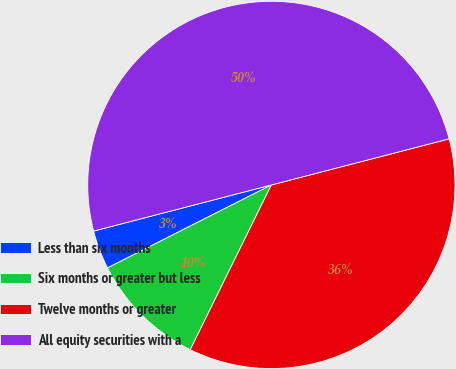Convert chart. <chart><loc_0><loc_0><loc_500><loc_500><pie_chart><fcel>Less than six months<fcel>Six months or greater but less<fcel>Twelve months or greater<fcel>All equity securities with a<nl><fcel>3.42%<fcel>10.26%<fcel>36.32%<fcel>50.0%<nl></chart> 